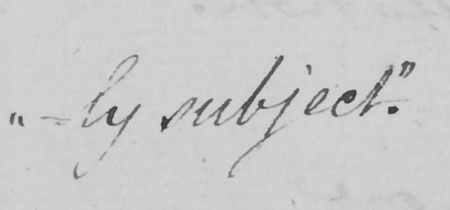Can you tell me what this handwritten text says? -ly subject . " 